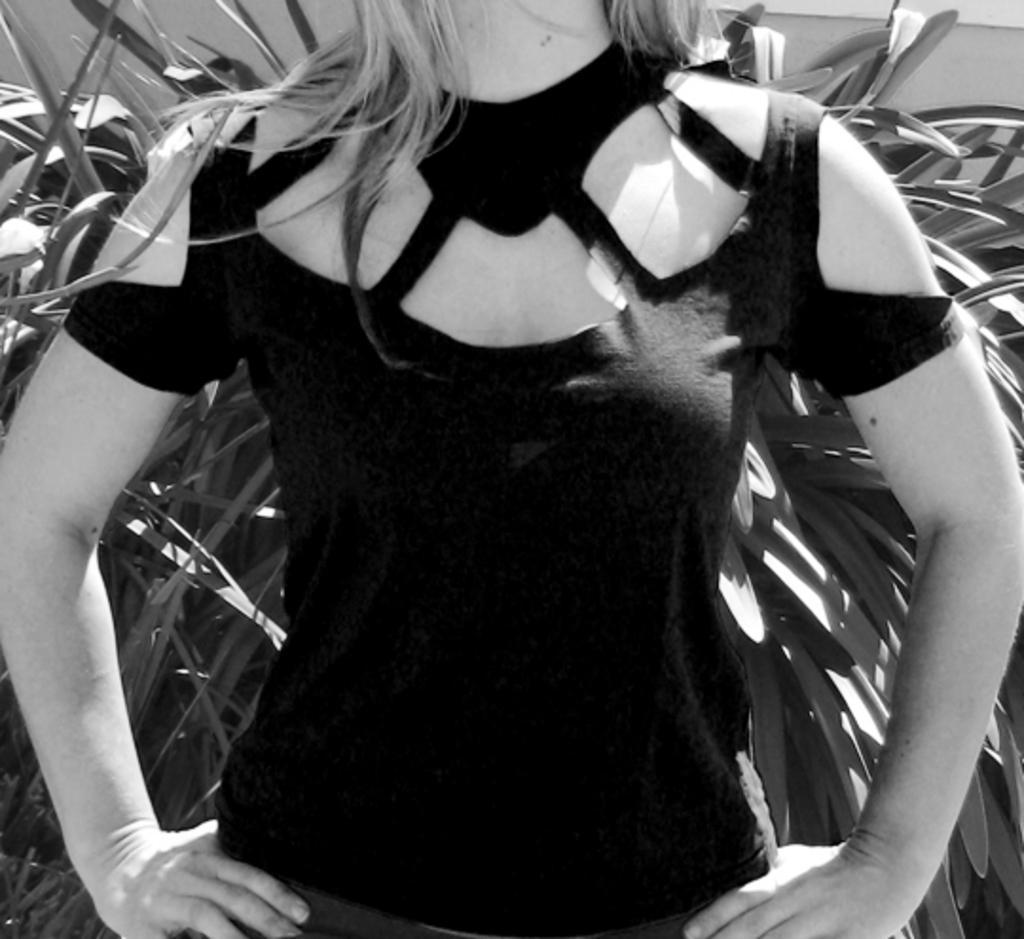In one or two sentences, can you explain what this image depicts? It is the black and white image in which we can see the woman without the head. In the background there are plants. 